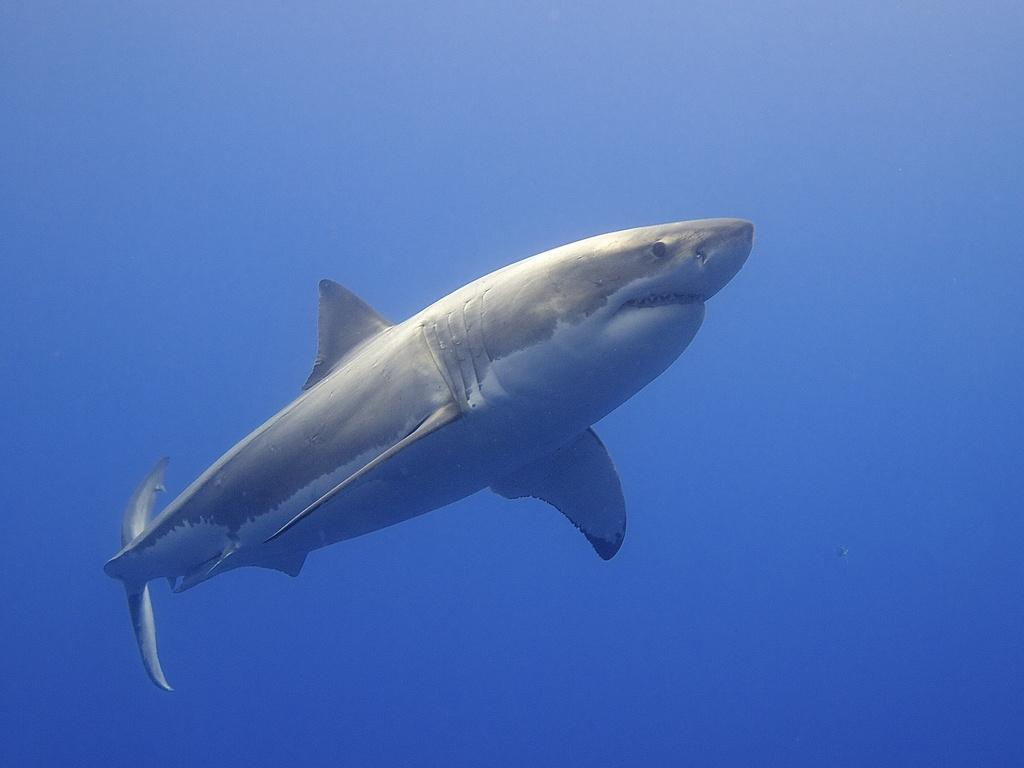What animal can be seen in the water in the image? There is a shark in the water in the image. What color is predominant in the background of the image? The background color is blue. What type of lunch is the shark eating in the image? There is no lunch present in the image, as it features a shark in the water with a blue background. 